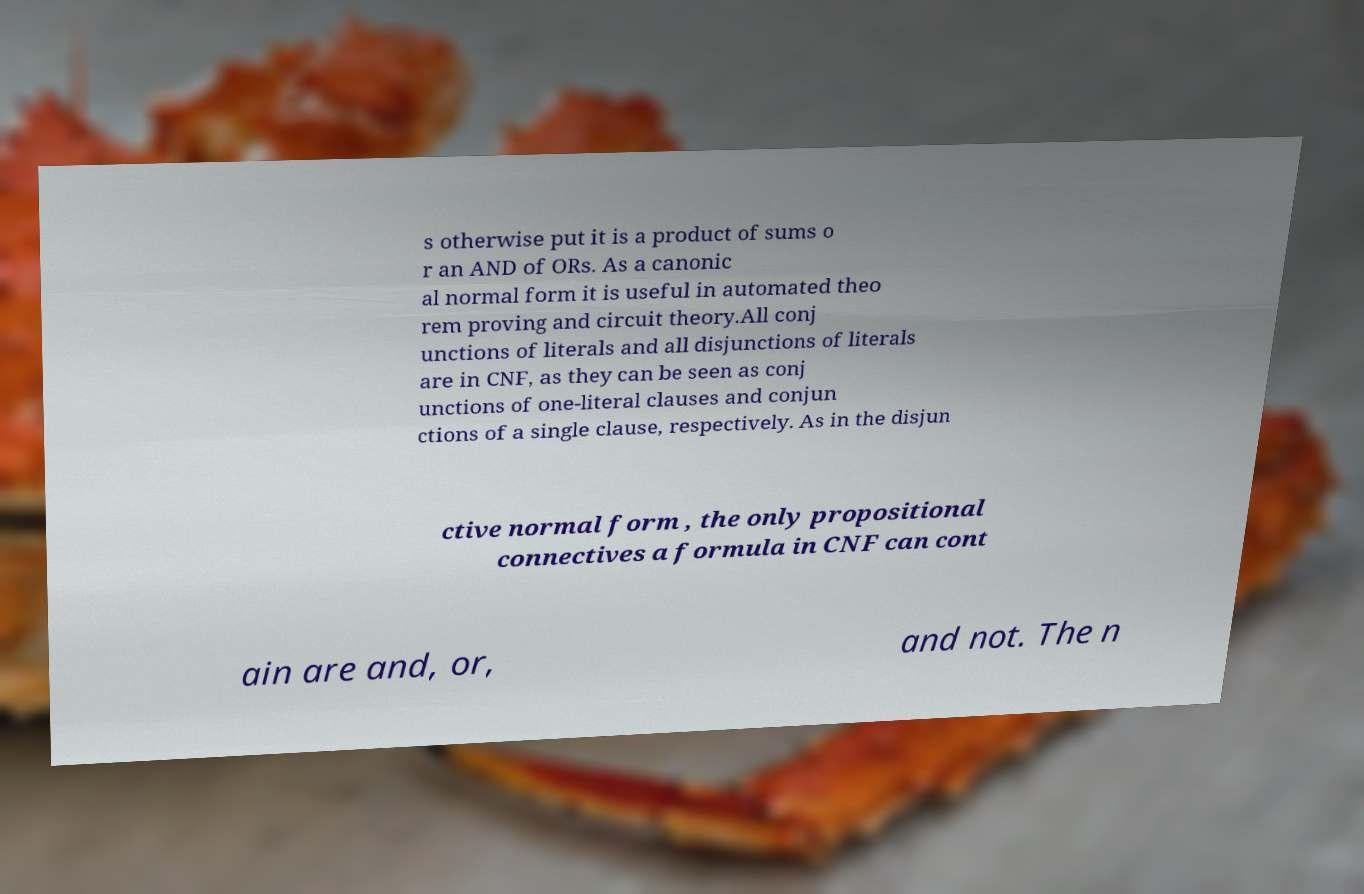Could you extract and type out the text from this image? s otherwise put it is a product of sums o r an AND of ORs. As a canonic al normal form it is useful in automated theo rem proving and circuit theory.All conj unctions of literals and all disjunctions of literals are in CNF, as they can be seen as conj unctions of one-literal clauses and conjun ctions of a single clause, respectively. As in the disjun ctive normal form , the only propositional connectives a formula in CNF can cont ain are and, or, and not. The n 